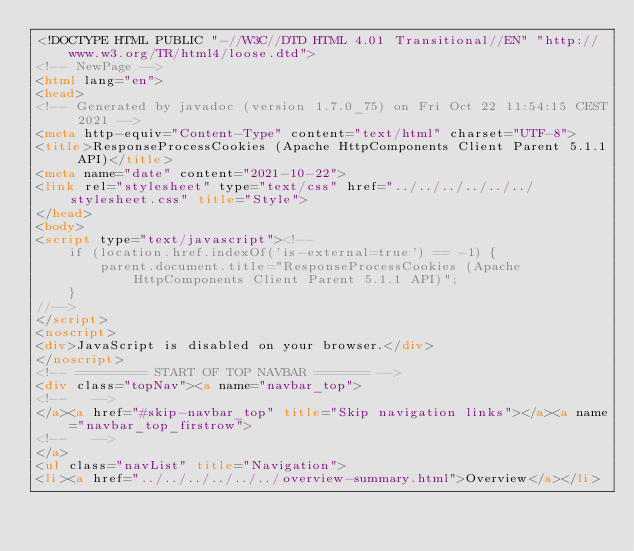Convert code to text. <code><loc_0><loc_0><loc_500><loc_500><_HTML_><!DOCTYPE HTML PUBLIC "-//W3C//DTD HTML 4.01 Transitional//EN" "http://www.w3.org/TR/html4/loose.dtd">
<!-- NewPage -->
<html lang="en">
<head>
<!-- Generated by javadoc (version 1.7.0_75) on Fri Oct 22 11:54:15 CEST 2021 -->
<meta http-equiv="Content-Type" content="text/html" charset="UTF-8">
<title>ResponseProcessCookies (Apache HttpComponents Client Parent 5.1.1 API)</title>
<meta name="date" content="2021-10-22">
<link rel="stylesheet" type="text/css" href="../../../../../../stylesheet.css" title="Style">
</head>
<body>
<script type="text/javascript"><!--
    if (location.href.indexOf('is-external=true') == -1) {
        parent.document.title="ResponseProcessCookies (Apache HttpComponents Client Parent 5.1.1 API)";
    }
//-->
</script>
<noscript>
<div>JavaScript is disabled on your browser.</div>
</noscript>
<!-- ========= START OF TOP NAVBAR ======= -->
<div class="topNav"><a name="navbar_top">
<!--   -->
</a><a href="#skip-navbar_top" title="Skip navigation links"></a><a name="navbar_top_firstrow">
<!--   -->
</a>
<ul class="navList" title="Navigation">
<li><a href="../../../../../../overview-summary.html">Overview</a></li></code> 